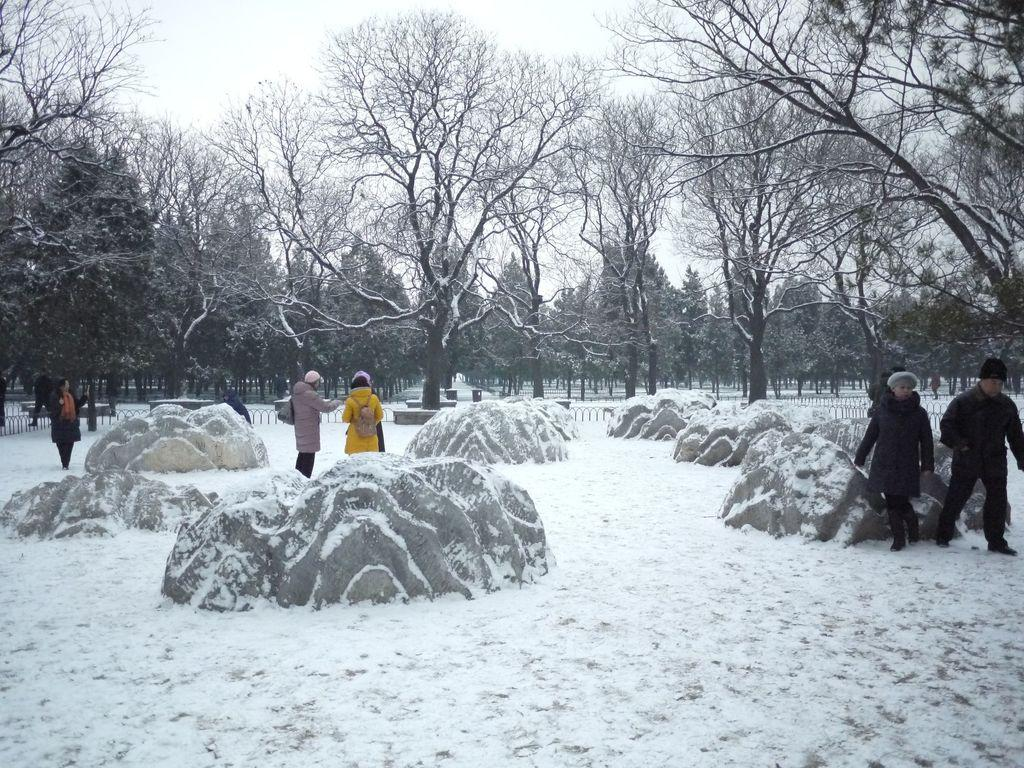How many persons are in the image? There are persons standing in the image. What is visible beneath the persons' feet in the image? The ground is visible in the image. What type of natural features can be seen in the image? There are rocks and trees in the image. What is visible above the persons' heads in the image? The sky is visible in the image. What type of weather condition is depicted in the image? There is snow in the image, indicating a cold or wintry environment. What hobbies do the persons in the image have? There is no information about the persons' hobbies in the image. What is the desire of the rocks in the image? Rocks do not have desires, as they are inanimate objects. 